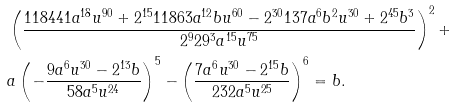Convert formula to latex. <formula><loc_0><loc_0><loc_500><loc_500>& \left ( \frac { 1 1 8 4 4 1 a ^ { 1 8 } u ^ { 9 0 } + 2 ^ { 1 5 } 1 1 8 6 3 a ^ { 1 2 } b u ^ { 6 0 } - 2 ^ { 3 0 } 1 3 7 a ^ { 6 } b ^ { 2 } u ^ { 3 0 } + 2 ^ { 4 5 } b ^ { 3 } } { 2 ^ { 9 } 2 9 ^ { 3 } a ^ { 1 5 } u ^ { 7 5 } } \right ) ^ { 2 } + \\ & a \left ( - \frac { 9 a ^ { 6 } u ^ { 3 0 } - 2 ^ { 1 3 } b } { 5 8 a ^ { 5 } u ^ { 2 4 } } \right ) ^ { 5 } - \left ( \frac { 7 a ^ { 6 } u ^ { 3 0 } - 2 ^ { 1 5 } b } { 2 3 2 a ^ { 5 } u ^ { 2 5 } } \right ) ^ { 6 } = b .</formula> 